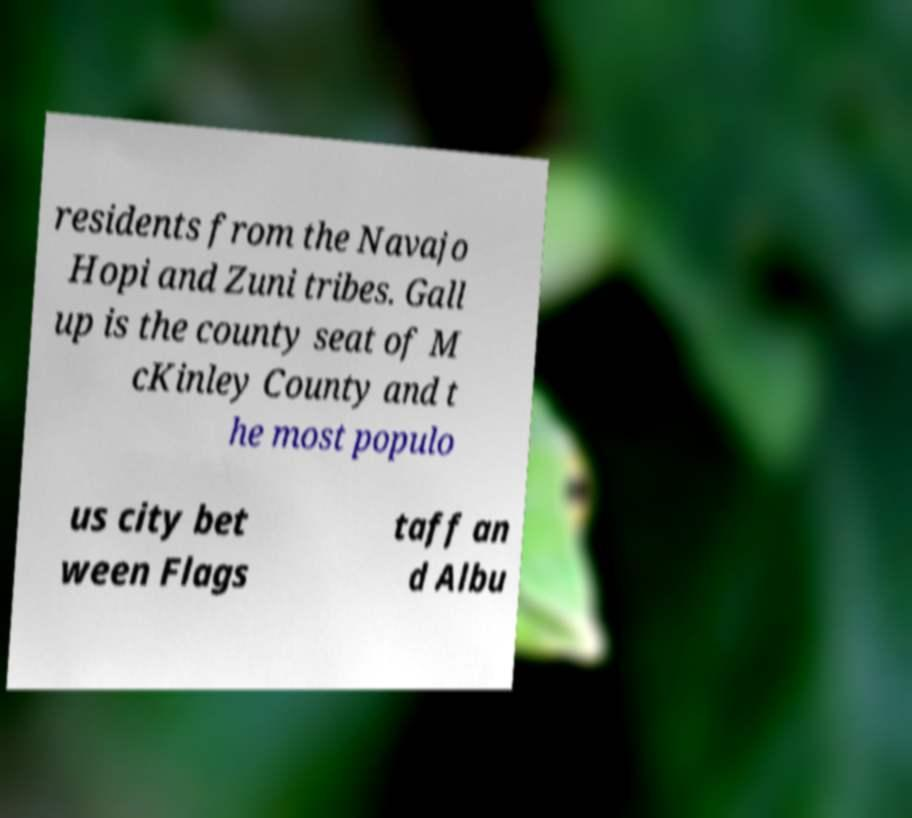For documentation purposes, I need the text within this image transcribed. Could you provide that? residents from the Navajo Hopi and Zuni tribes. Gall up is the county seat of M cKinley County and t he most populo us city bet ween Flags taff an d Albu 